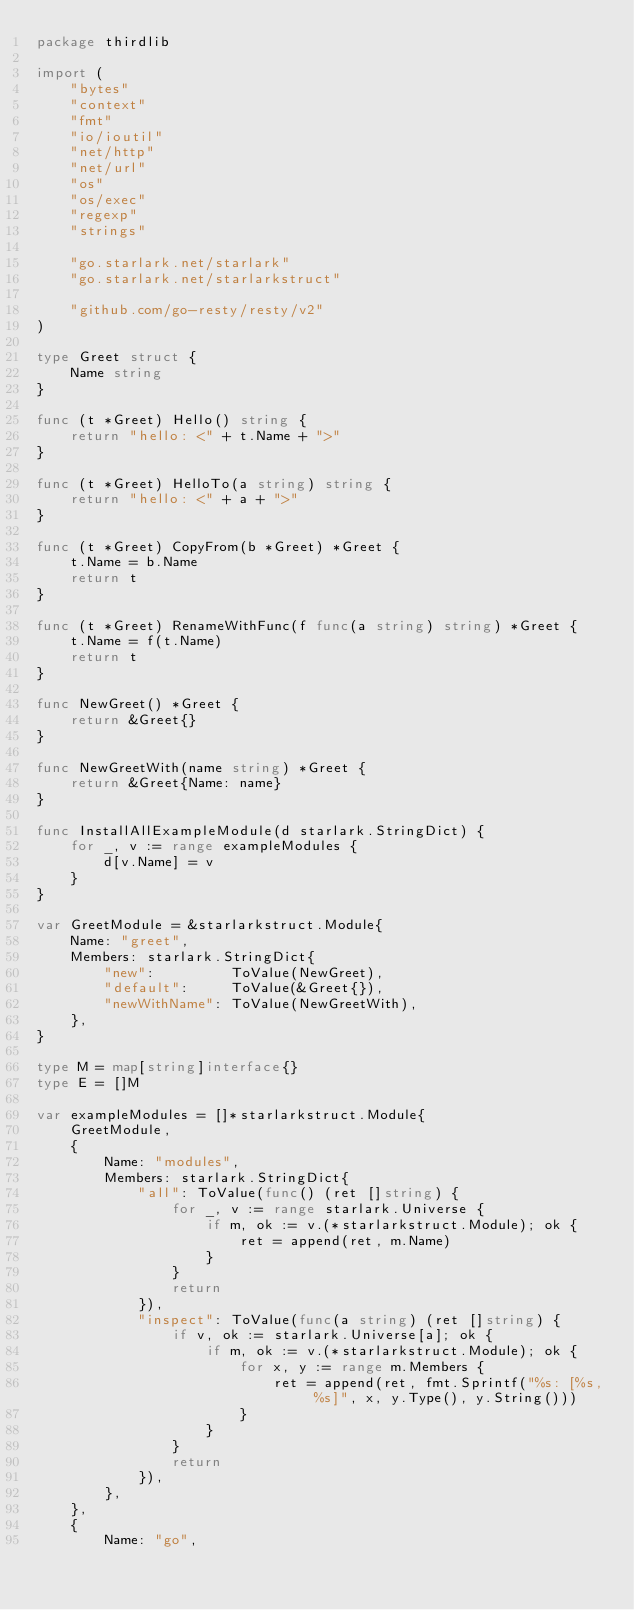Convert code to text. <code><loc_0><loc_0><loc_500><loc_500><_Go_>package thirdlib

import (
	"bytes"
	"context"
	"fmt"
	"io/ioutil"
	"net/http"
	"net/url"
	"os"
	"os/exec"
	"regexp"
	"strings"

	"go.starlark.net/starlark"
	"go.starlark.net/starlarkstruct"

	"github.com/go-resty/resty/v2"
)

type Greet struct {
	Name string
}

func (t *Greet) Hello() string {
	return "hello: <" + t.Name + ">"
}

func (t *Greet) HelloTo(a string) string {
	return "hello: <" + a + ">"
}

func (t *Greet) CopyFrom(b *Greet) *Greet {
	t.Name = b.Name
	return t
}

func (t *Greet) RenameWithFunc(f func(a string) string) *Greet {
	t.Name = f(t.Name)
	return t
}

func NewGreet() *Greet {
	return &Greet{}
}

func NewGreetWith(name string) *Greet {
	return &Greet{Name: name}
}

func InstallAllExampleModule(d starlark.StringDict) {
	for _, v := range exampleModules {
		d[v.Name] = v
	}
}

var GreetModule = &starlarkstruct.Module{
	Name: "greet",
	Members: starlark.StringDict{
		"new":         ToValue(NewGreet),
		"default":     ToValue(&Greet{}),
		"newWithName": ToValue(NewGreetWith),
	},
}

type M = map[string]interface{}
type E = []M

var exampleModules = []*starlarkstruct.Module{
	GreetModule,
	{
		Name: "modules",
		Members: starlark.StringDict{
			"all": ToValue(func() (ret []string) {
				for _, v := range starlark.Universe {
					if m, ok := v.(*starlarkstruct.Module); ok {
						ret = append(ret, m.Name)
					}
				}
				return
			}),
			"inspect": ToValue(func(a string) (ret []string) {
				if v, ok := starlark.Universe[a]; ok {
					if m, ok := v.(*starlarkstruct.Module); ok {
						for x, y := range m.Members {
							ret = append(ret, fmt.Sprintf("%s: [%s, %s]", x, y.Type(), y.String()))
						}
					}
				}
				return
			}),
		},
	},
	{
		Name: "go",</code> 